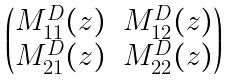Convert formula to latex. <formula><loc_0><loc_0><loc_500><loc_500>\begin{pmatrix} M ^ { D } _ { 1 1 } ( z ) & M ^ { D } _ { 1 2 } ( z ) \\ M ^ { D } _ { 2 1 } ( z ) & M ^ { D } _ { 2 2 } ( z ) \end{pmatrix}</formula> 